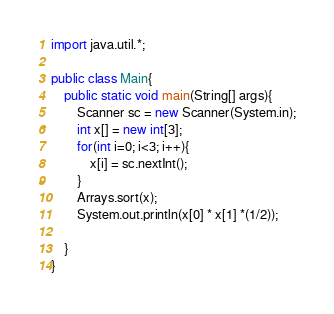<code> <loc_0><loc_0><loc_500><loc_500><_Java_>import java.util.*;
 
public class Main{
	public static void main(String[] args){
        Scanner sc = new Scanner(System.in);
        int x[] = new int[3];
        for(int i=0; i<3; i++){
            x[i] = sc.nextInt();
        }
        Arrays.sort(x);
        System.out.println(x[0] * x[1] *(1/2));
        
    }
}</code> 